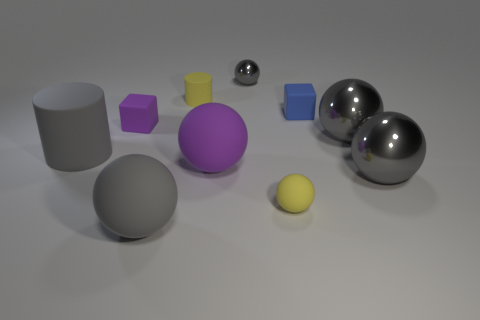What material is the cube that is on the left side of the small cube that is behind the small purple cube made of?
Make the answer very short. Rubber. Are there any objects made of the same material as the blue cube?
Keep it short and to the point. Yes. What is the material of the gray cylinder that is the same size as the purple rubber ball?
Your answer should be compact. Rubber. What size is the shiny object that is behind the yellow matte object that is behind the yellow object in front of the large purple matte object?
Your answer should be very brief. Small. Is there a tiny yellow rubber sphere that is behind the metallic sphere in front of the big gray rubber cylinder?
Ensure brevity in your answer.  No. There is a big purple rubber thing; is it the same shape as the big object behind the large rubber cylinder?
Offer a terse response. Yes. There is a rubber ball that is on the left side of the yellow matte cylinder; what color is it?
Give a very brief answer. Gray. What is the size of the purple object behind the large matte sphere on the right side of the yellow rubber cylinder?
Your answer should be compact. Small. There is a gray object behind the blue rubber cube; is its shape the same as the big purple rubber object?
Ensure brevity in your answer.  Yes. There is a tiny gray object that is the same shape as the large purple thing; what material is it?
Ensure brevity in your answer.  Metal. 